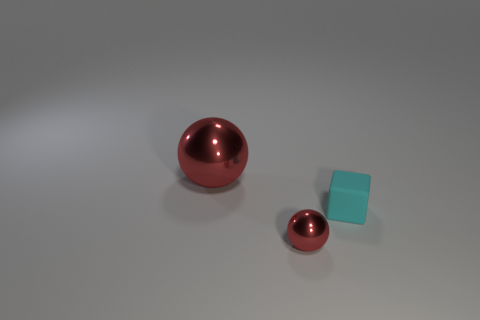Add 2 big blocks. How many objects exist? 5 Subtract all spheres. How many objects are left? 1 Add 1 tiny red spheres. How many tiny red spheres are left? 2 Add 2 tiny metal objects. How many tiny metal objects exist? 3 Subtract 0 gray balls. How many objects are left? 3 Subtract all metallic spheres. Subtract all tiny brown rubber blocks. How many objects are left? 1 